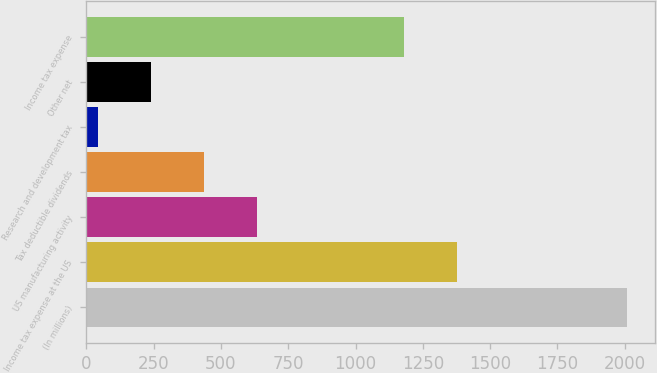Convert chart to OTSL. <chart><loc_0><loc_0><loc_500><loc_500><bar_chart><fcel>(In millions)<fcel>Income tax expense at the US<fcel>US manufacturing activity<fcel>Tax deductible dividends<fcel>Research and development tax<fcel>Other net<fcel>Income tax expense<nl><fcel>2010<fcel>1377.7<fcel>633.1<fcel>436.4<fcel>43<fcel>239.7<fcel>1181<nl></chart> 